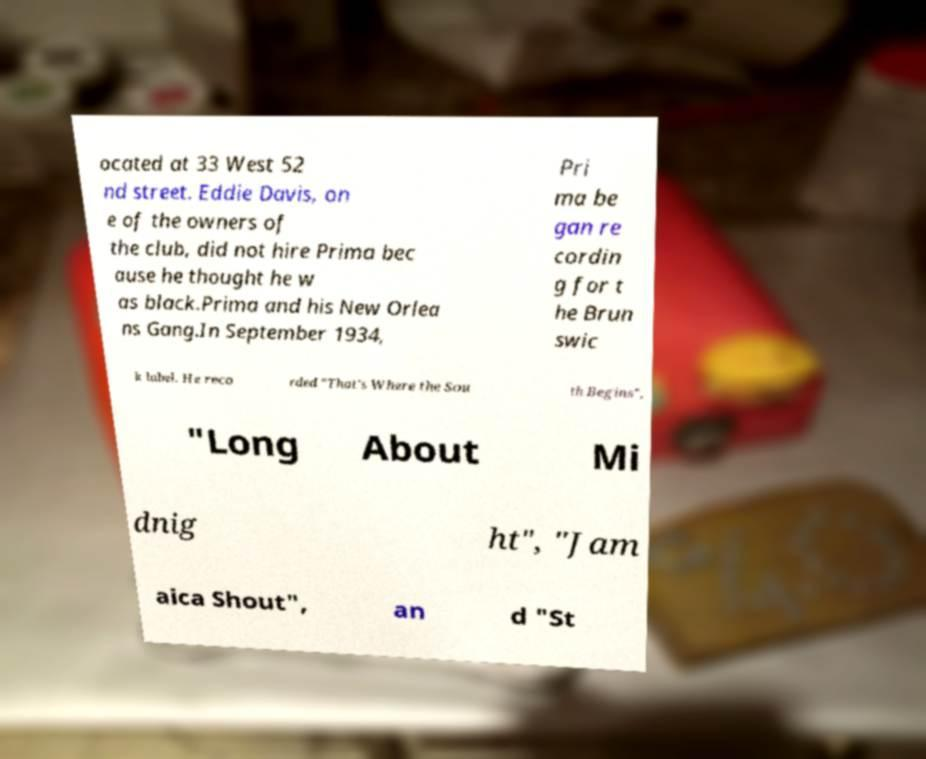I need the written content from this picture converted into text. Can you do that? ocated at 33 West 52 nd street. Eddie Davis, on e of the owners of the club, did not hire Prima bec ause he thought he w as black.Prima and his New Orlea ns Gang.In September 1934, Pri ma be gan re cordin g for t he Brun swic k label. He reco rded "That's Where the Sou th Begins", "Long About Mi dnig ht", "Jam aica Shout", an d "St 